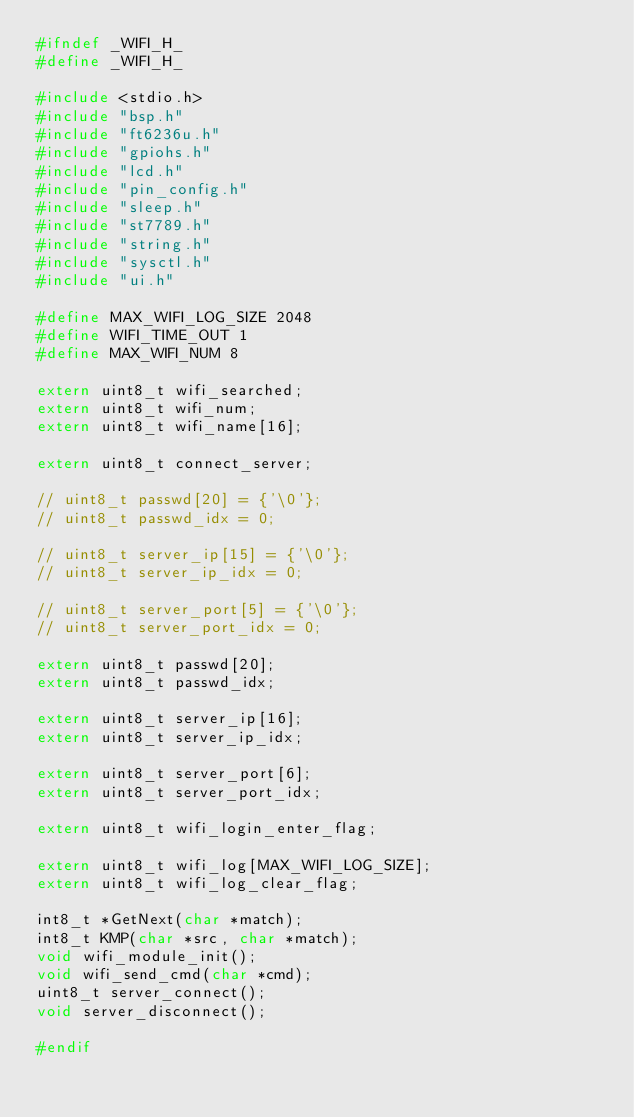<code> <loc_0><loc_0><loc_500><loc_500><_C_>#ifndef _WIFI_H_
#define _WIFI_H_

#include <stdio.h>
#include "bsp.h"
#include "ft6236u.h"
#include "gpiohs.h"
#include "lcd.h"
#include "pin_config.h"
#include "sleep.h"
#include "st7789.h"
#include "string.h"
#include "sysctl.h"
#include "ui.h"

#define MAX_WIFI_LOG_SIZE 2048
#define WIFI_TIME_OUT 1
#define MAX_WIFI_NUM 8

extern uint8_t wifi_searched;
extern uint8_t wifi_num;
extern uint8_t wifi_name[16];

extern uint8_t connect_server;

// uint8_t passwd[20] = {'\0'};
// uint8_t passwd_idx = 0;

// uint8_t server_ip[15] = {'\0'};
// uint8_t server_ip_idx = 0;

// uint8_t server_port[5] = {'\0'};
// uint8_t server_port_idx = 0;

extern uint8_t passwd[20];
extern uint8_t passwd_idx;

extern uint8_t server_ip[16];
extern uint8_t server_ip_idx;

extern uint8_t server_port[6];
extern uint8_t server_port_idx;

extern uint8_t wifi_login_enter_flag;

extern uint8_t wifi_log[MAX_WIFI_LOG_SIZE];
extern uint8_t wifi_log_clear_flag;

int8_t *GetNext(char *match);
int8_t KMP(char *src, char *match);
void wifi_module_init();
void wifi_send_cmd(char *cmd);
uint8_t server_connect();
void server_disconnect();

#endif</code> 